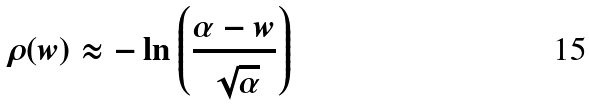<formula> <loc_0><loc_0><loc_500><loc_500>\rho ( w ) \approx - \ln \left ( \frac { \alpha - w } { \sqrt { \alpha } } \right )</formula> 